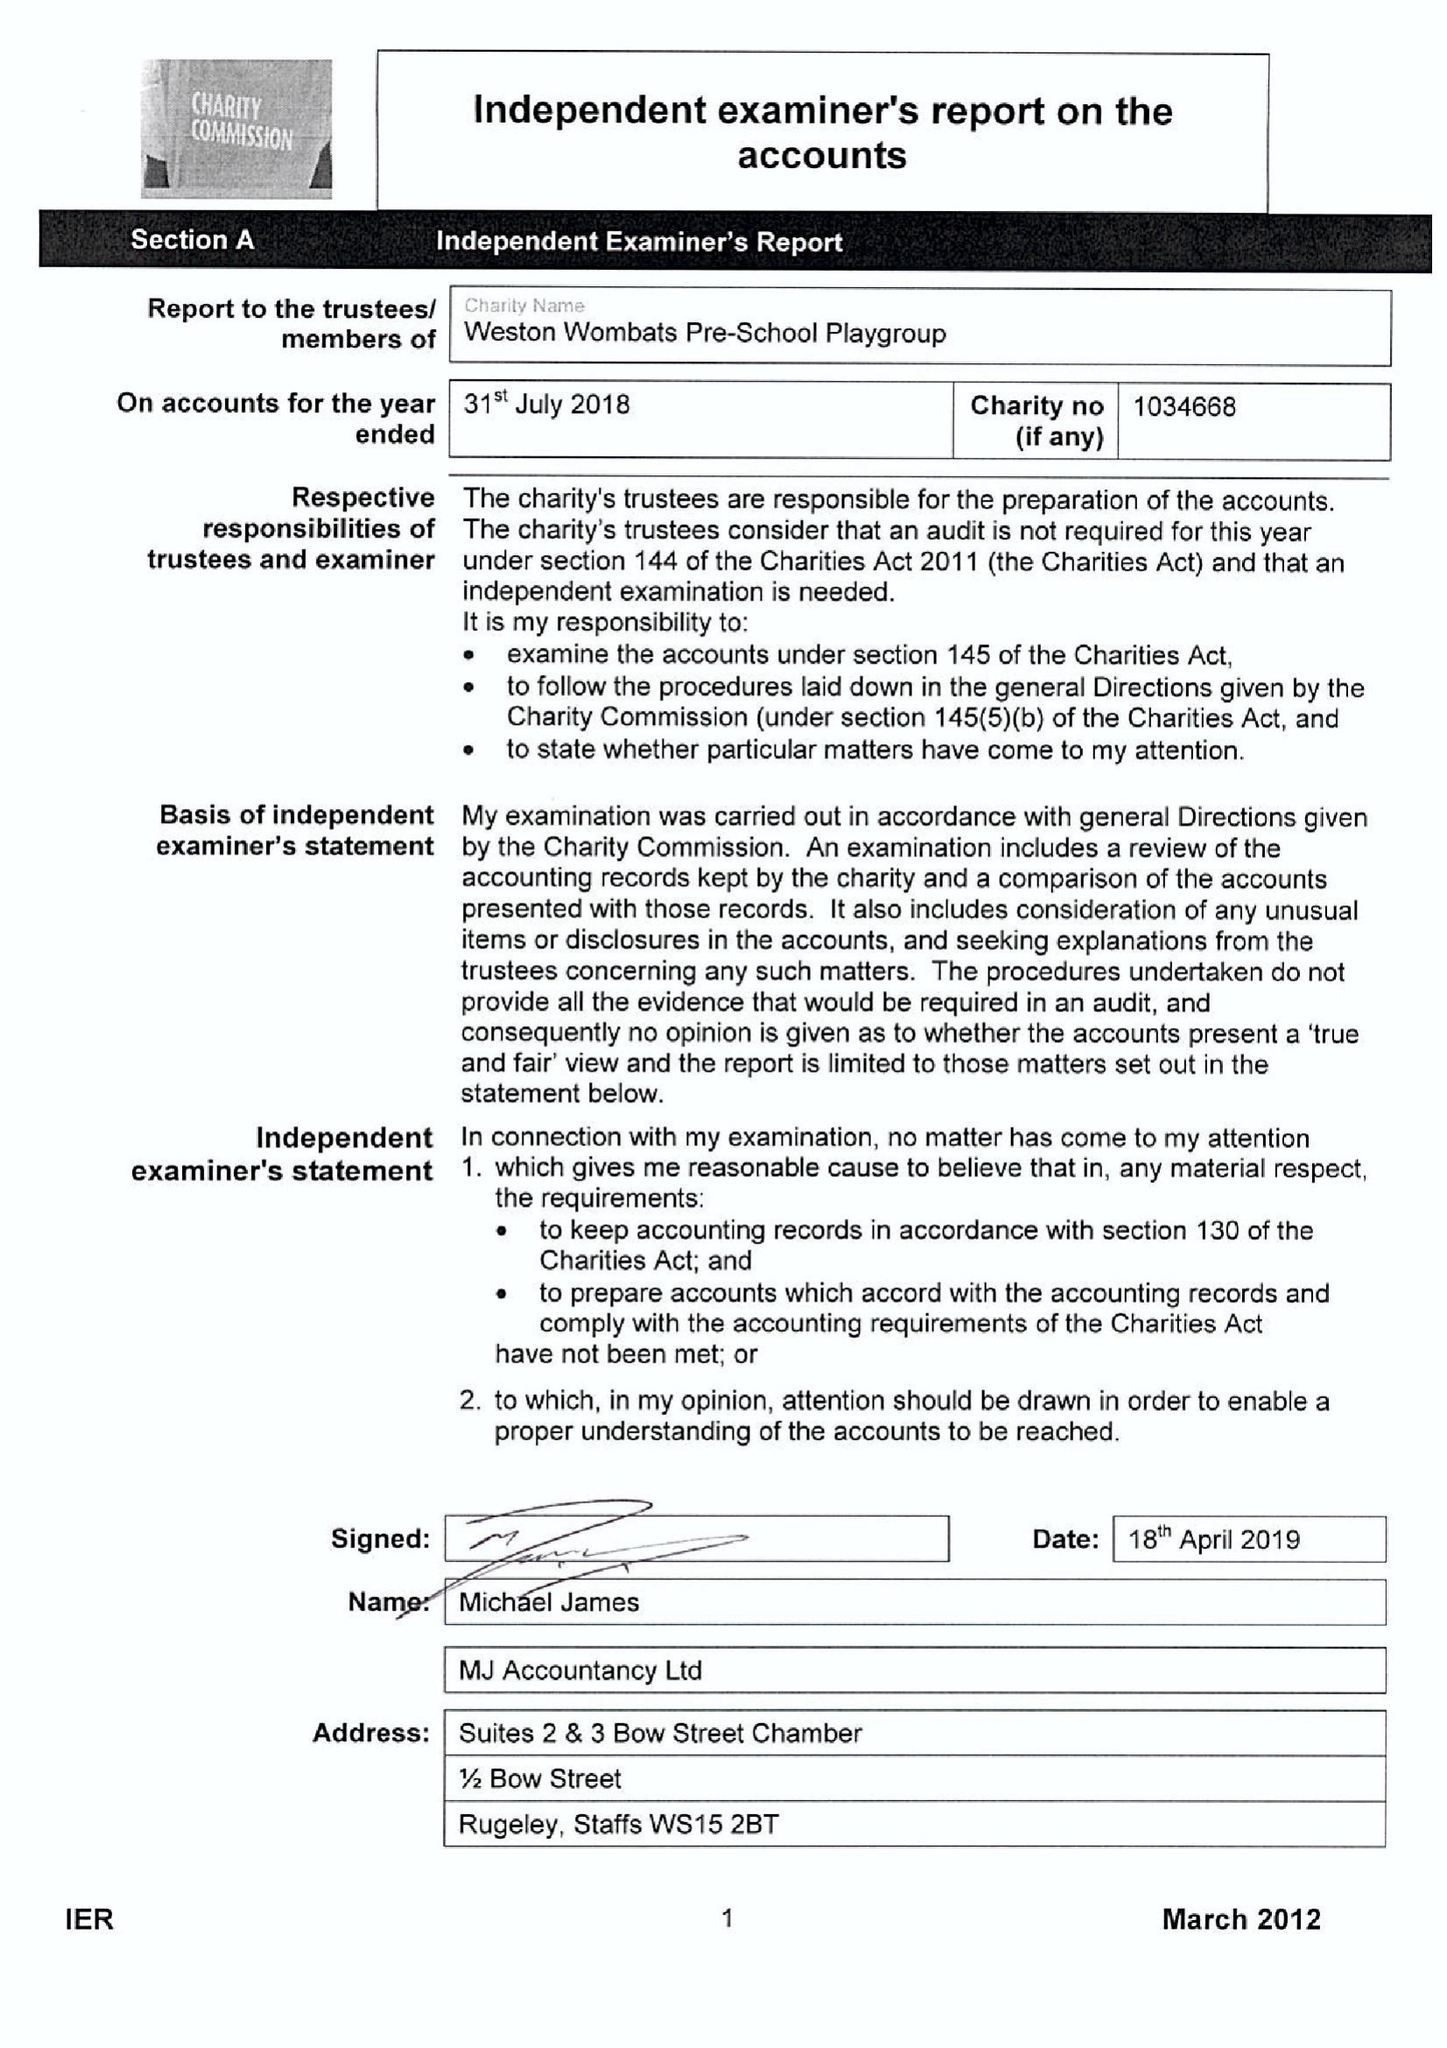What is the value for the address__street_line?
Answer the question using a single word or phrase. WESTON ROAD 